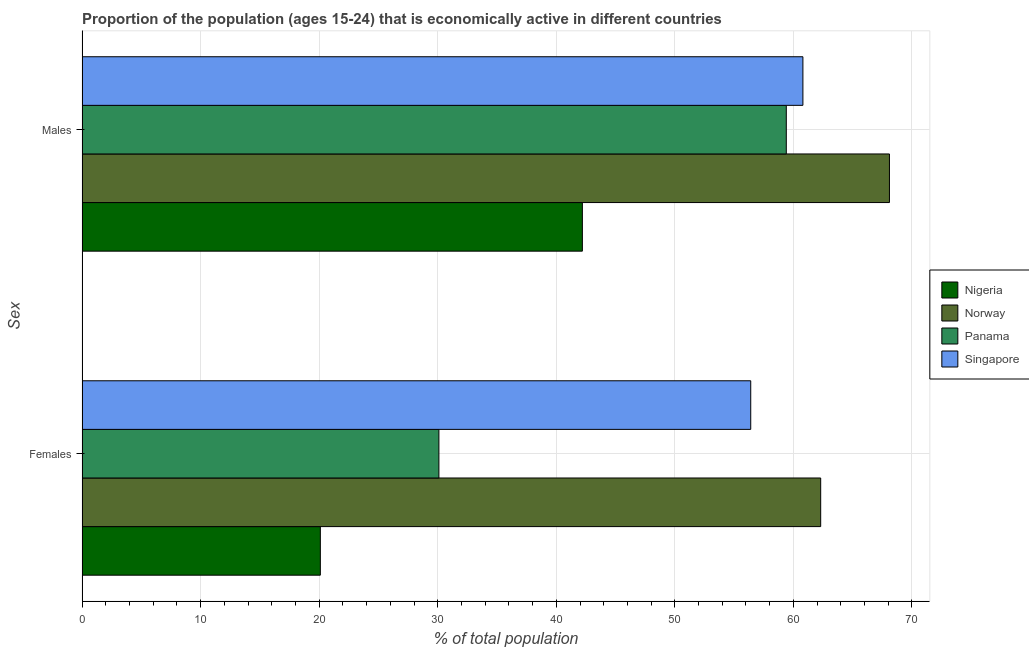How many groups of bars are there?
Ensure brevity in your answer.  2. Are the number of bars per tick equal to the number of legend labels?
Your answer should be very brief. Yes. How many bars are there on the 2nd tick from the top?
Your response must be concise. 4. How many bars are there on the 1st tick from the bottom?
Ensure brevity in your answer.  4. What is the label of the 2nd group of bars from the top?
Offer a terse response. Females. What is the percentage of economically active female population in Panama?
Make the answer very short. 30.1. Across all countries, what is the maximum percentage of economically active male population?
Provide a short and direct response. 68.1. Across all countries, what is the minimum percentage of economically active male population?
Make the answer very short. 42.2. In which country was the percentage of economically active female population maximum?
Offer a very short reply. Norway. In which country was the percentage of economically active male population minimum?
Keep it short and to the point. Nigeria. What is the total percentage of economically active female population in the graph?
Provide a short and direct response. 168.9. What is the difference between the percentage of economically active female population in Singapore and that in Nigeria?
Offer a very short reply. 36.3. What is the difference between the percentage of economically active male population in Panama and the percentage of economically active female population in Nigeria?
Provide a short and direct response. 39.3. What is the average percentage of economically active female population per country?
Give a very brief answer. 42.23. What is the difference between the percentage of economically active male population and percentage of economically active female population in Panama?
Your response must be concise. 29.3. What is the ratio of the percentage of economically active female population in Singapore to that in Nigeria?
Provide a succinct answer. 2.81. Is the percentage of economically active male population in Singapore less than that in Norway?
Make the answer very short. Yes. In how many countries, is the percentage of economically active male population greater than the average percentage of economically active male population taken over all countries?
Keep it short and to the point. 3. What does the 1st bar from the top in Males represents?
Keep it short and to the point. Singapore. How many bars are there?
Provide a short and direct response. 8. Are all the bars in the graph horizontal?
Give a very brief answer. Yes. How many countries are there in the graph?
Offer a very short reply. 4. Does the graph contain any zero values?
Provide a succinct answer. No. Does the graph contain grids?
Make the answer very short. Yes. How many legend labels are there?
Your answer should be compact. 4. What is the title of the graph?
Keep it short and to the point. Proportion of the population (ages 15-24) that is economically active in different countries. What is the label or title of the X-axis?
Provide a succinct answer. % of total population. What is the label or title of the Y-axis?
Your response must be concise. Sex. What is the % of total population of Nigeria in Females?
Your response must be concise. 20.1. What is the % of total population of Norway in Females?
Provide a short and direct response. 62.3. What is the % of total population of Panama in Females?
Make the answer very short. 30.1. What is the % of total population of Singapore in Females?
Offer a very short reply. 56.4. What is the % of total population of Nigeria in Males?
Offer a very short reply. 42.2. What is the % of total population in Norway in Males?
Your response must be concise. 68.1. What is the % of total population in Panama in Males?
Keep it short and to the point. 59.4. What is the % of total population in Singapore in Males?
Give a very brief answer. 60.8. Across all Sex, what is the maximum % of total population in Nigeria?
Make the answer very short. 42.2. Across all Sex, what is the maximum % of total population of Norway?
Your answer should be compact. 68.1. Across all Sex, what is the maximum % of total population in Panama?
Your answer should be compact. 59.4. Across all Sex, what is the maximum % of total population in Singapore?
Your response must be concise. 60.8. Across all Sex, what is the minimum % of total population in Nigeria?
Ensure brevity in your answer.  20.1. Across all Sex, what is the minimum % of total population in Norway?
Give a very brief answer. 62.3. Across all Sex, what is the minimum % of total population of Panama?
Offer a very short reply. 30.1. Across all Sex, what is the minimum % of total population of Singapore?
Ensure brevity in your answer.  56.4. What is the total % of total population of Nigeria in the graph?
Your answer should be compact. 62.3. What is the total % of total population of Norway in the graph?
Provide a succinct answer. 130.4. What is the total % of total population in Panama in the graph?
Your answer should be very brief. 89.5. What is the total % of total population of Singapore in the graph?
Offer a very short reply. 117.2. What is the difference between the % of total population of Nigeria in Females and that in Males?
Ensure brevity in your answer.  -22.1. What is the difference between the % of total population of Panama in Females and that in Males?
Provide a succinct answer. -29.3. What is the difference between the % of total population of Singapore in Females and that in Males?
Give a very brief answer. -4.4. What is the difference between the % of total population of Nigeria in Females and the % of total population of Norway in Males?
Provide a short and direct response. -48. What is the difference between the % of total population of Nigeria in Females and the % of total population of Panama in Males?
Your answer should be very brief. -39.3. What is the difference between the % of total population in Nigeria in Females and the % of total population in Singapore in Males?
Provide a succinct answer. -40.7. What is the difference between the % of total population of Norway in Females and the % of total population of Panama in Males?
Your response must be concise. 2.9. What is the difference between the % of total population of Norway in Females and the % of total population of Singapore in Males?
Give a very brief answer. 1.5. What is the difference between the % of total population in Panama in Females and the % of total population in Singapore in Males?
Your response must be concise. -30.7. What is the average % of total population in Nigeria per Sex?
Provide a succinct answer. 31.15. What is the average % of total population in Norway per Sex?
Keep it short and to the point. 65.2. What is the average % of total population of Panama per Sex?
Ensure brevity in your answer.  44.75. What is the average % of total population of Singapore per Sex?
Keep it short and to the point. 58.6. What is the difference between the % of total population of Nigeria and % of total population of Norway in Females?
Ensure brevity in your answer.  -42.2. What is the difference between the % of total population of Nigeria and % of total population of Singapore in Females?
Offer a very short reply. -36.3. What is the difference between the % of total population of Norway and % of total population of Panama in Females?
Provide a short and direct response. 32.2. What is the difference between the % of total population of Panama and % of total population of Singapore in Females?
Make the answer very short. -26.3. What is the difference between the % of total population of Nigeria and % of total population of Norway in Males?
Offer a very short reply. -25.9. What is the difference between the % of total population in Nigeria and % of total population in Panama in Males?
Give a very brief answer. -17.2. What is the difference between the % of total population of Nigeria and % of total population of Singapore in Males?
Provide a short and direct response. -18.6. What is the ratio of the % of total population in Nigeria in Females to that in Males?
Provide a short and direct response. 0.48. What is the ratio of the % of total population of Norway in Females to that in Males?
Provide a short and direct response. 0.91. What is the ratio of the % of total population in Panama in Females to that in Males?
Offer a terse response. 0.51. What is the ratio of the % of total population in Singapore in Females to that in Males?
Give a very brief answer. 0.93. What is the difference between the highest and the second highest % of total population of Nigeria?
Offer a very short reply. 22.1. What is the difference between the highest and the second highest % of total population of Panama?
Your answer should be very brief. 29.3. What is the difference between the highest and the second highest % of total population of Singapore?
Your answer should be very brief. 4.4. What is the difference between the highest and the lowest % of total population in Nigeria?
Ensure brevity in your answer.  22.1. What is the difference between the highest and the lowest % of total population of Panama?
Ensure brevity in your answer.  29.3. 